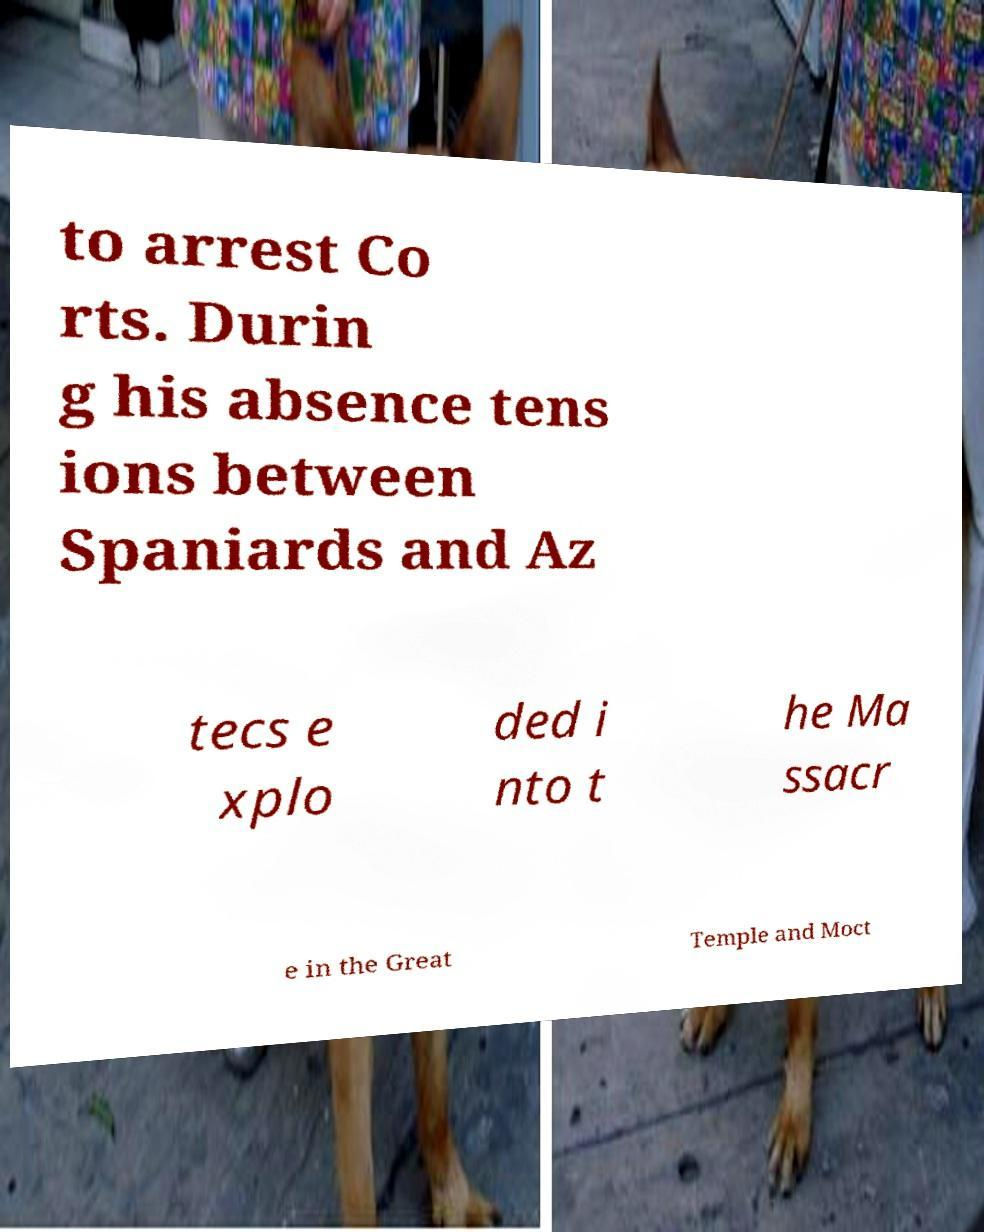I need the written content from this picture converted into text. Can you do that? to arrest Co rts. Durin g his absence tens ions between Spaniards and Az tecs e xplo ded i nto t he Ma ssacr e in the Great Temple and Moct 